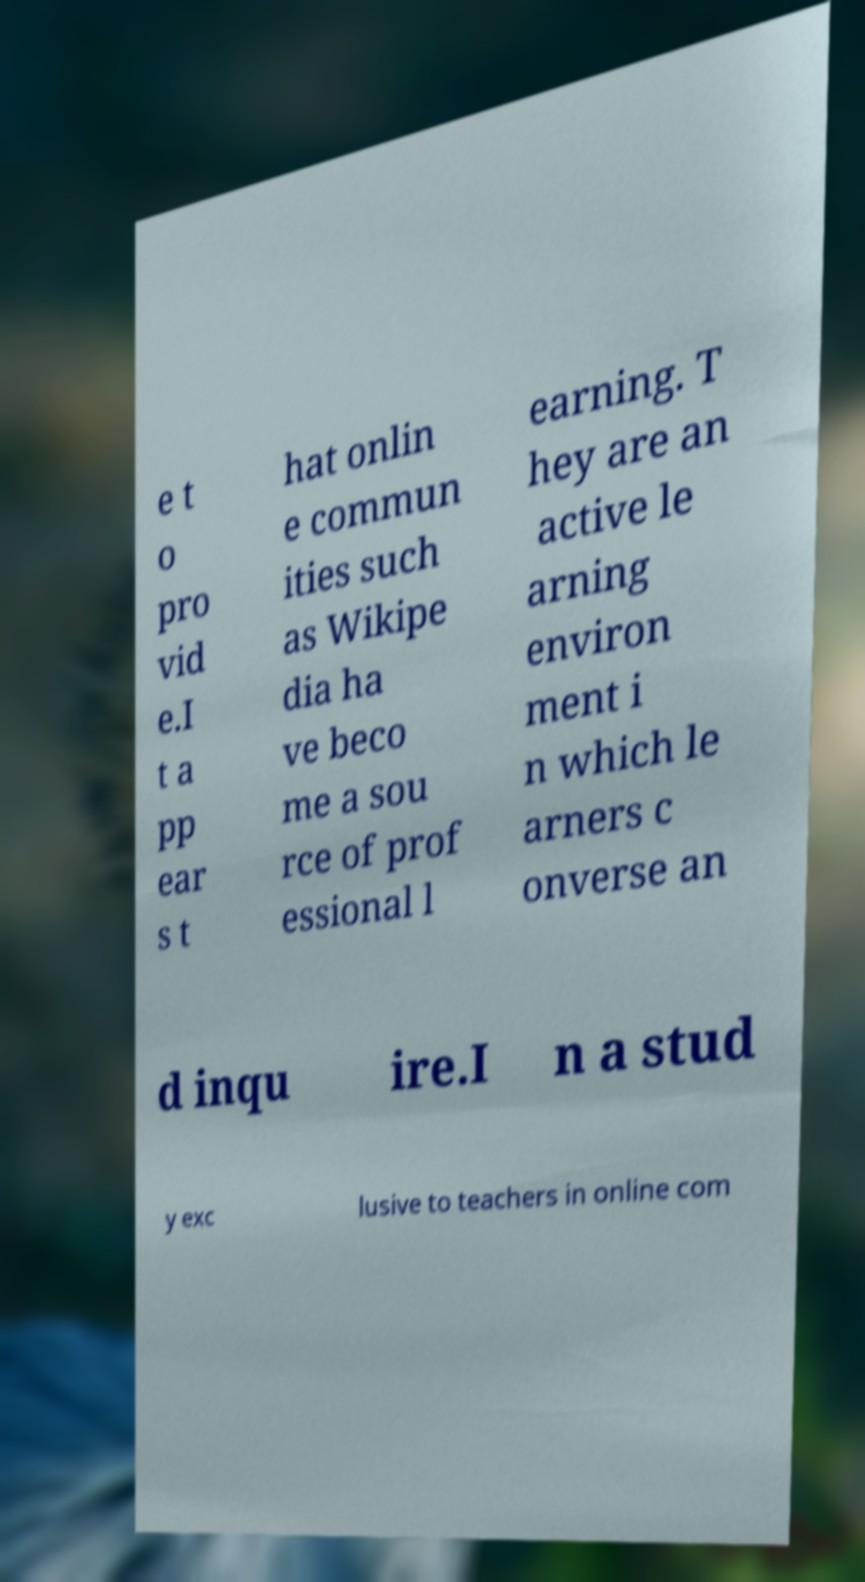For documentation purposes, I need the text within this image transcribed. Could you provide that? e t o pro vid e.I t a pp ear s t hat onlin e commun ities such as Wikipe dia ha ve beco me a sou rce of prof essional l earning. T hey are an active le arning environ ment i n which le arners c onverse an d inqu ire.I n a stud y exc lusive to teachers in online com 